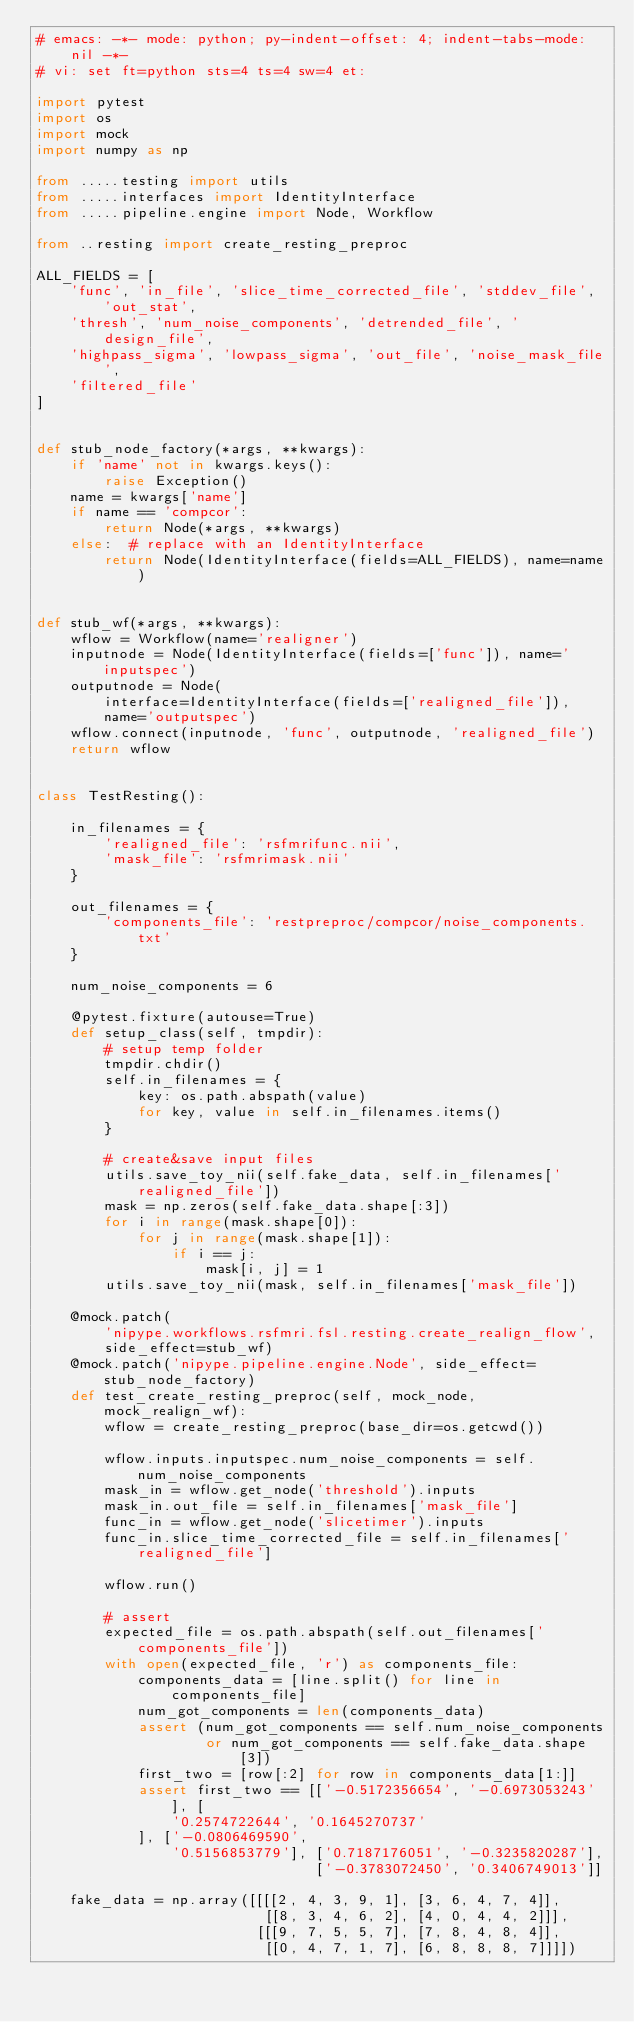<code> <loc_0><loc_0><loc_500><loc_500><_Python_># emacs: -*- mode: python; py-indent-offset: 4; indent-tabs-mode: nil -*-
# vi: set ft=python sts=4 ts=4 sw=4 et:

import pytest
import os
import mock
import numpy as np

from .....testing import utils
from .....interfaces import IdentityInterface
from .....pipeline.engine import Node, Workflow

from ..resting import create_resting_preproc

ALL_FIELDS = [
    'func', 'in_file', 'slice_time_corrected_file', 'stddev_file', 'out_stat',
    'thresh', 'num_noise_components', 'detrended_file', 'design_file',
    'highpass_sigma', 'lowpass_sigma', 'out_file', 'noise_mask_file',
    'filtered_file'
]


def stub_node_factory(*args, **kwargs):
    if 'name' not in kwargs.keys():
        raise Exception()
    name = kwargs['name']
    if name == 'compcor':
        return Node(*args, **kwargs)
    else:  # replace with an IdentityInterface
        return Node(IdentityInterface(fields=ALL_FIELDS), name=name)


def stub_wf(*args, **kwargs):
    wflow = Workflow(name='realigner')
    inputnode = Node(IdentityInterface(fields=['func']), name='inputspec')
    outputnode = Node(
        interface=IdentityInterface(fields=['realigned_file']),
        name='outputspec')
    wflow.connect(inputnode, 'func', outputnode, 'realigned_file')
    return wflow


class TestResting():

    in_filenames = {
        'realigned_file': 'rsfmrifunc.nii',
        'mask_file': 'rsfmrimask.nii'
    }

    out_filenames = {
        'components_file': 'restpreproc/compcor/noise_components.txt'
    }

    num_noise_components = 6

    @pytest.fixture(autouse=True)
    def setup_class(self, tmpdir):
        # setup temp folder
        tmpdir.chdir()
        self.in_filenames = {
            key: os.path.abspath(value)
            for key, value in self.in_filenames.items()
        }

        # create&save input files
        utils.save_toy_nii(self.fake_data, self.in_filenames['realigned_file'])
        mask = np.zeros(self.fake_data.shape[:3])
        for i in range(mask.shape[0]):
            for j in range(mask.shape[1]):
                if i == j:
                    mask[i, j] = 1
        utils.save_toy_nii(mask, self.in_filenames['mask_file'])

    @mock.patch(
        'nipype.workflows.rsfmri.fsl.resting.create_realign_flow',
        side_effect=stub_wf)
    @mock.patch('nipype.pipeline.engine.Node', side_effect=stub_node_factory)
    def test_create_resting_preproc(self, mock_node, mock_realign_wf):
        wflow = create_resting_preproc(base_dir=os.getcwd())

        wflow.inputs.inputspec.num_noise_components = self.num_noise_components
        mask_in = wflow.get_node('threshold').inputs
        mask_in.out_file = self.in_filenames['mask_file']
        func_in = wflow.get_node('slicetimer').inputs
        func_in.slice_time_corrected_file = self.in_filenames['realigned_file']

        wflow.run()

        # assert
        expected_file = os.path.abspath(self.out_filenames['components_file'])
        with open(expected_file, 'r') as components_file:
            components_data = [line.split() for line in components_file]
            num_got_components = len(components_data)
            assert (num_got_components == self.num_noise_components
                    or num_got_components == self.fake_data.shape[3])
            first_two = [row[:2] for row in components_data[1:]]
            assert first_two == [['-0.5172356654', '-0.6973053243'], [
                '0.2574722644', '0.1645270737'
            ], ['-0.0806469590',
                '0.5156853779'], ['0.7187176051', '-0.3235820287'],
                                 ['-0.3783072450', '0.3406749013']]

    fake_data = np.array([[[[2, 4, 3, 9, 1], [3, 6, 4, 7, 4]],
                           [[8, 3, 4, 6, 2], [4, 0, 4, 4, 2]]],
                          [[[9, 7, 5, 5, 7], [7, 8, 4, 8, 4]],
                           [[0, 4, 7, 1, 7], [6, 8, 8, 8, 7]]]])
</code> 